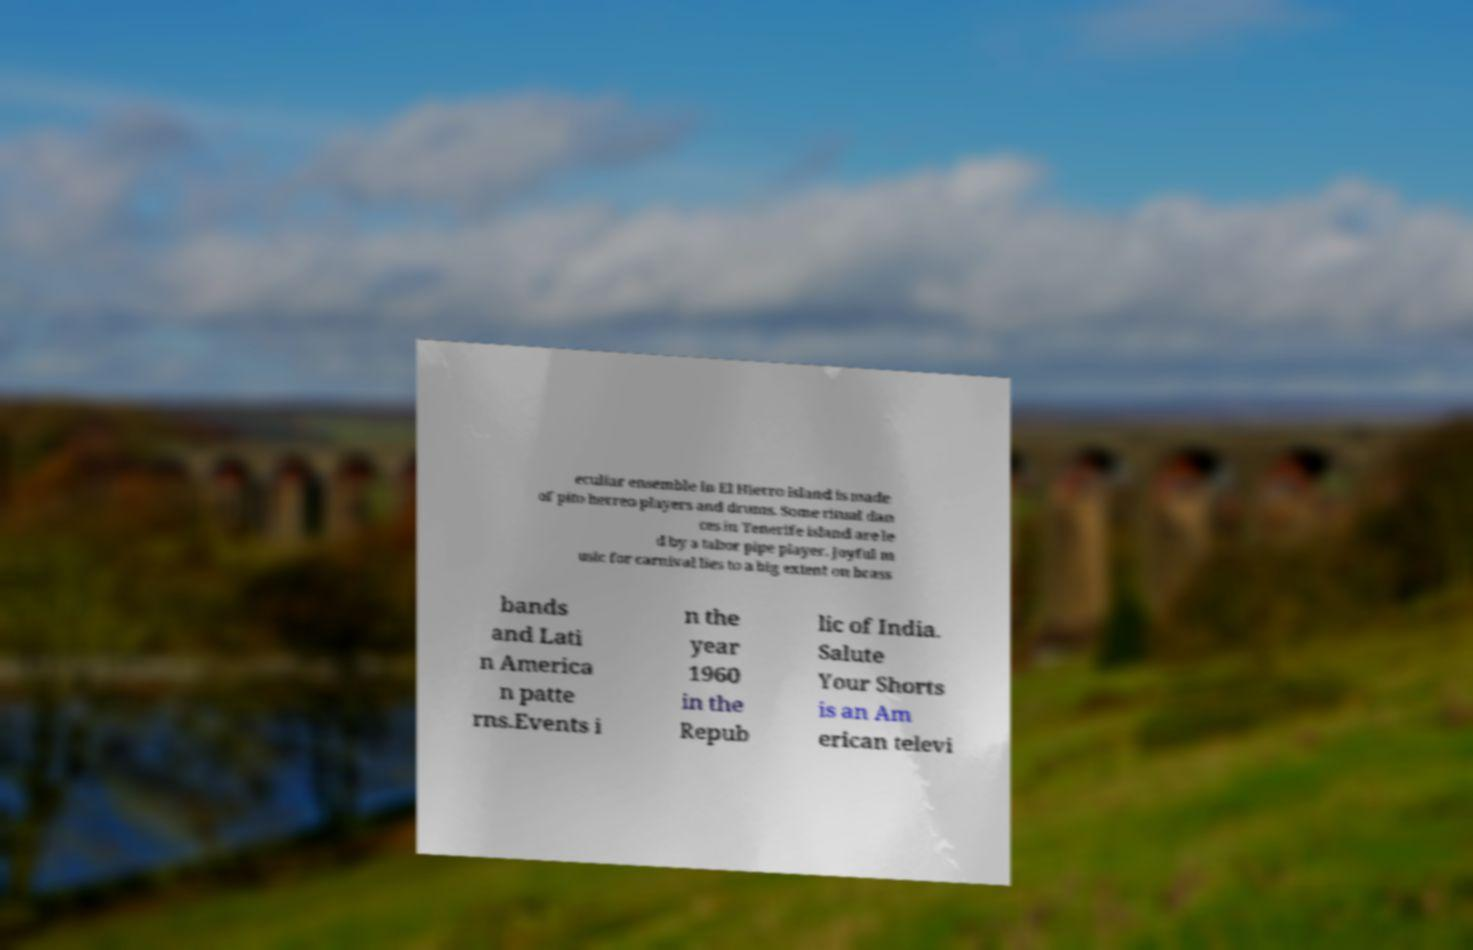Can you accurately transcribe the text from the provided image for me? eculiar ensemble in El Hierro island is made of pito herreo players and drums. Some ritual dan ces in Tenerife island are le d by a tabor pipe player. Joyful m usic for carnival lies to a big extent on brass bands and Lati n America n patte rns.Events i n the year 1960 in the Repub lic of India. Salute Your Shorts is an Am erican televi 